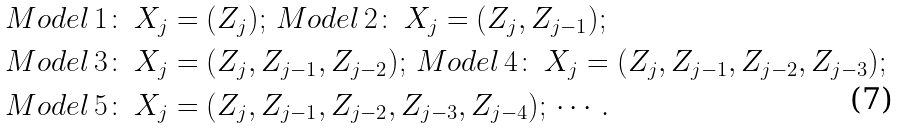Convert formula to latex. <formula><loc_0><loc_0><loc_500><loc_500>& { M o d e l } \, { 1 \colon } \, X _ { j } = ( Z _ { j } ) ; \, { M o d e l } \, { 2 \colon } \, X _ { j } = ( Z _ { j } , Z _ { j - 1 } ) ; \\ & { M o d e l } \, { 3 \colon } \, X _ { j } = ( Z _ { j } , Z _ { j - 1 } , Z _ { j - 2 } ) ; \, { M o d e l } \, { 4 \colon } \, X _ { j } = ( Z _ { j } , Z _ { j - 1 } , Z _ { j - 2 } , Z _ { j - 3 } ) ; \\ & { M o d e l } \, { 5 \colon } \, X _ { j } = ( Z _ { j } , Z _ { j - 1 } , Z _ { j - 2 } , Z _ { j - 3 } , Z _ { j - 4 } ) ; \, \cdots .</formula> 